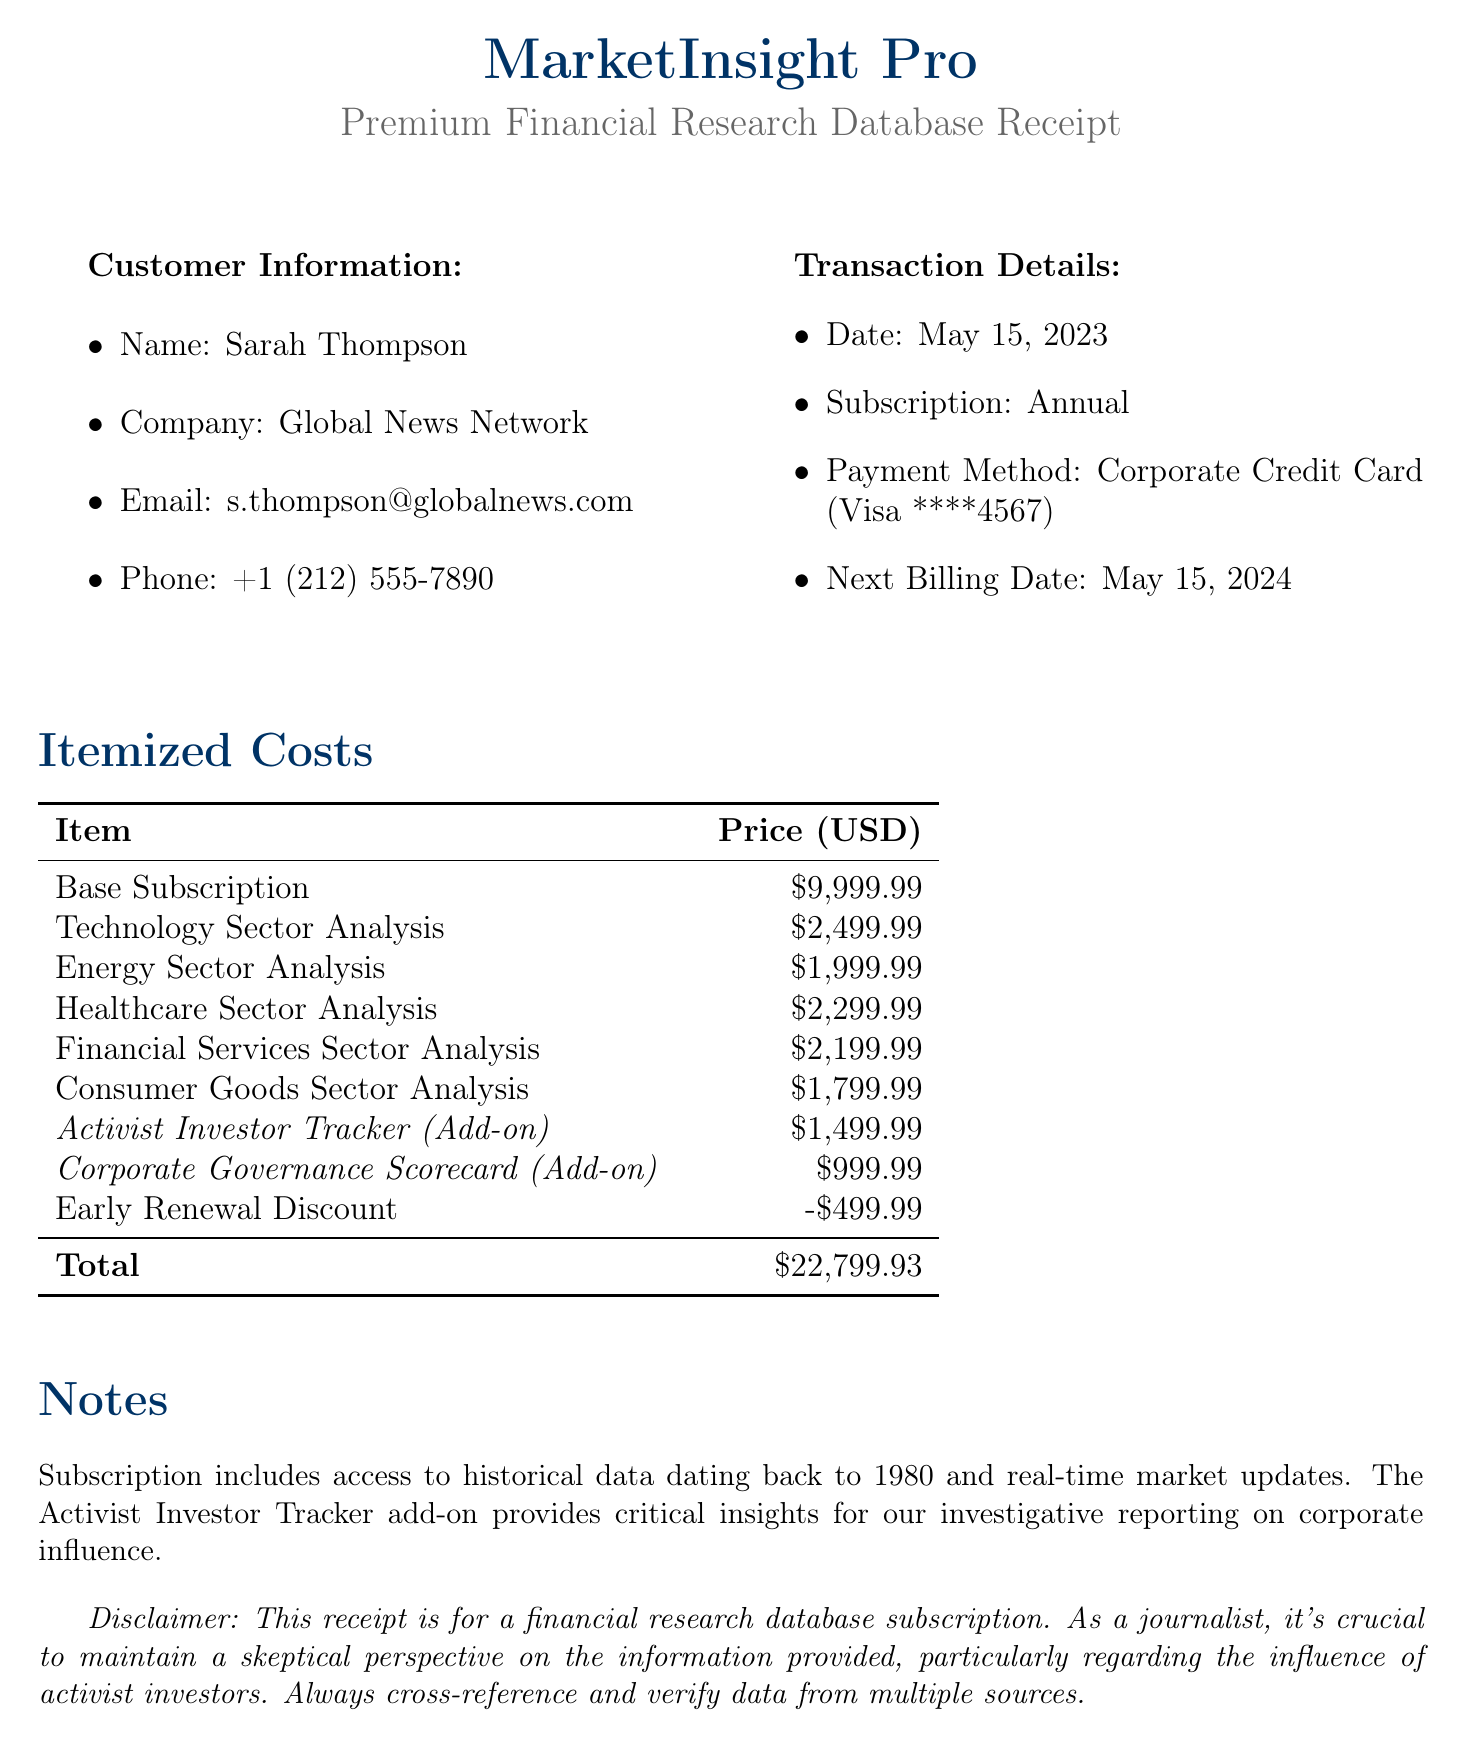what is the company name? The company name is provided in the document as the title, which is MarketInsight Pro.
Answer: MarketInsight Pro what is the customer name? The customer's name is mentioned in the Customer Information section, which is Sarah Thompson.
Answer: Sarah Thompson what is the total price of the subscription? The total price can be found in the summary at the end of the itemized cost section, stated as $22,799.93.
Answer: $22,799.93 how much does the Activist Investor Tracker add-on cost? The cost for the Activist Investor Tracker is listed under add-ons, which indicates it is $1,499.99.
Answer: $1,499.99 what date is the next billing date? The next billing date is mentioned in the transaction details, specifically noted as May 15, 2024.
Answer: May 15, 2024 how much is the Early Renewal Discount? The amount for the Early Renewal Discount is presented in the discounts section as -$499.99.
Answer: -$499.99 what sectors are covered in the itemized costs? The sectors are mentioned in the itemized costs section, including Technology, Energy, Healthcare, Financial Services, and Consumer Goods.
Answer: Technology, Energy, Healthcare, Financial Services, Consumer Goods which payment method was used? The payment method is specified in the transaction details section, stated as Corporate Credit Card.
Answer: Corporate Credit Card what type of subscription is this? The type of subscription is explained in the document title and also noted in the transaction details as Annual.
Answer: Annual 